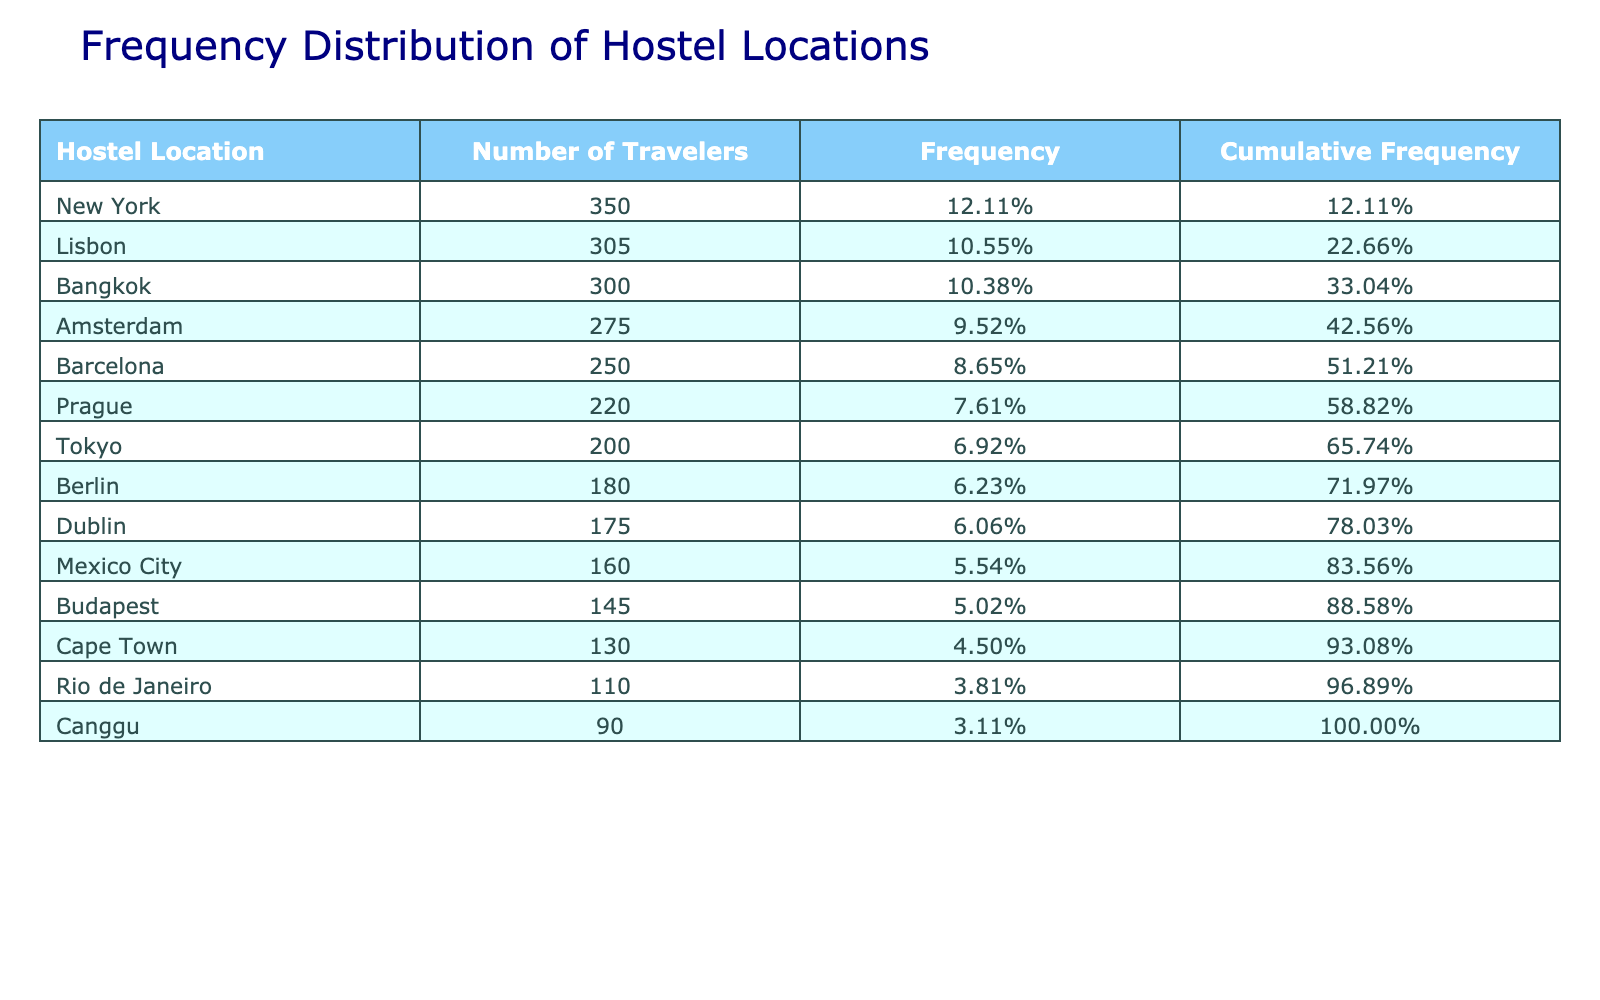What hostel location has the highest number of travelers? By examining the "Number of Travelers" column, we can see that New York has the highest value, which is 350.
Answer: New York What is the frequency percentage of travelers for Barcelona? To find the frequency percentage, first, we find the number of travelers for Barcelona, which is 250. The total number of travelers is 2,430 (the sum of all travelers). Therefore, the frequency is calculated as (250 / 2430) * 100%, which equals approximately 10.29%.
Answer: 10.29% Is Rio de Janeiro among the top three hostel locations by number of travelers? By observing the "Number of Travelers" values, Rio de Janeiro has 110 travelers, which is lower than the top three values: New York (350), Bangkok (300), and Amsterdam (275). Therefore, Rio de Janeiro is not in the top three.
Answer: No What is the cumulative frequency for the hostel location Tokyo? Tokyo has 200 travelers. To find its cumulative frequency, we first sum the travelers for locations ranked higher than Tokyo: New York (350), Bangkok (300), Amsterdam (275), and Barcelona (250). This equals 1,175 travelers. Therefore, the cumulative frequency is (1,175 + 200) / 2,430, which is approximately 57.59%.
Answer: 57.59% How many total travelers are there from the locations Lisbon and Canggu combined? The number of travelers from Lisbon is 305 (the sum of two entries: 150 and 155). Canggu has 90 travelers. Combining these, we get 305 + 90 = 395 travelers.
Answer: 395 